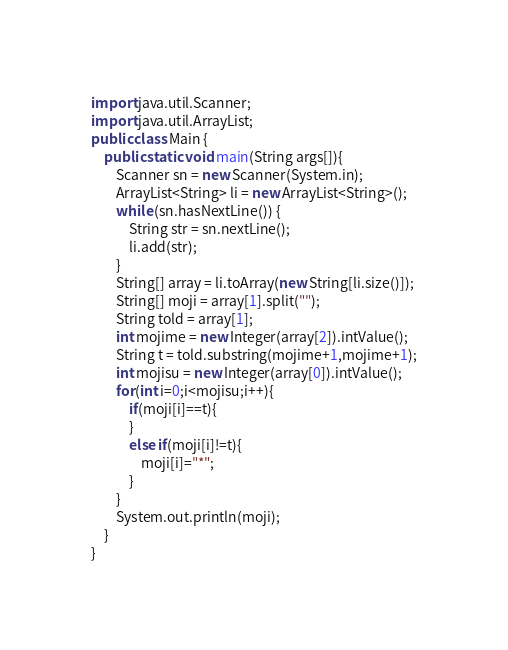Convert code to text. <code><loc_0><loc_0><loc_500><loc_500><_Java_>import java.util.Scanner;
import java.util.ArrayList;
public class Main {
    public static void main(String args[]){
        Scanner sn = new Scanner(System.in);
        ArrayList<String> li = new ArrayList<String>();
        while (sn.hasNextLine()) {
            String str = sn.nextLine();
            li.add(str);
        }
        String[] array = li.toArray(new String[li.size()]);
        String[] moji = array[1].split("");
        String told = array[1];
        int mojime = new Integer(array[2]).intValue();
        String t = told.substring(mojime+1,mojime+1);
        int mojisu = new Integer(array[0]).intValue();
        for(int i=0;i<mojisu;i++){
            if(moji[i]==t){
            }
            else if(moji[i]!=t){
                moji[i]="*";
            }
        }
        System.out.println(moji);
    }
}
</code> 